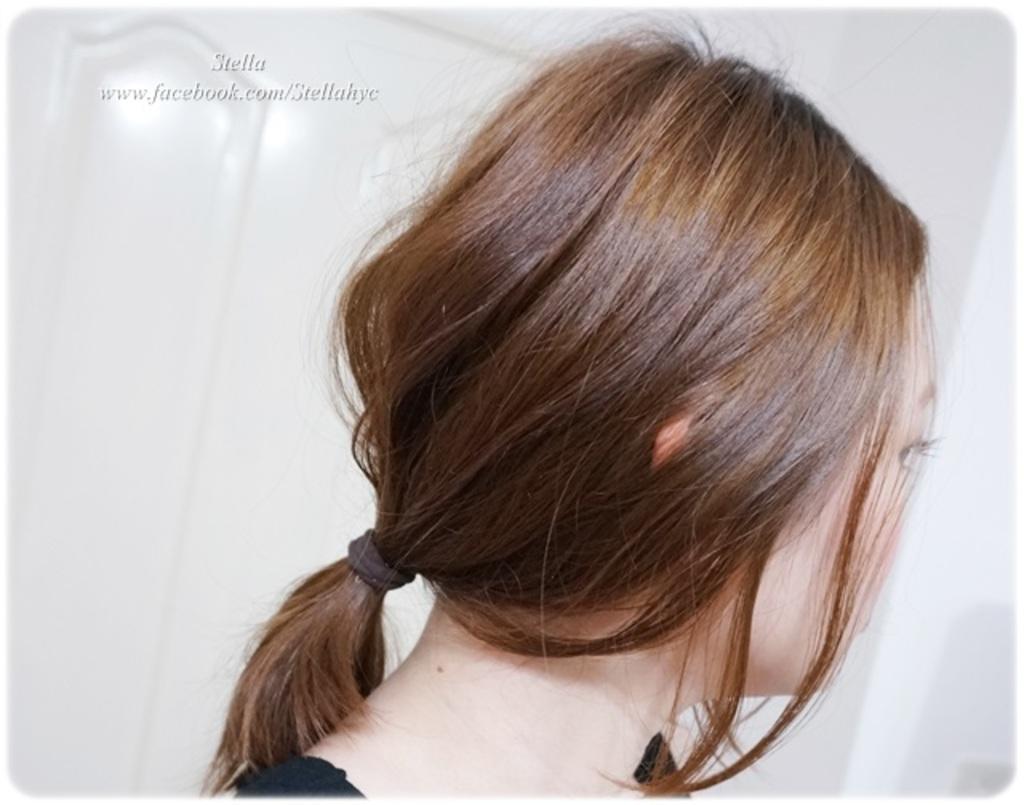Can you describe this image briefly? In this image there is a person , and there is a rubber band tied to her hair, and there is white color background and a watermark on the image. 